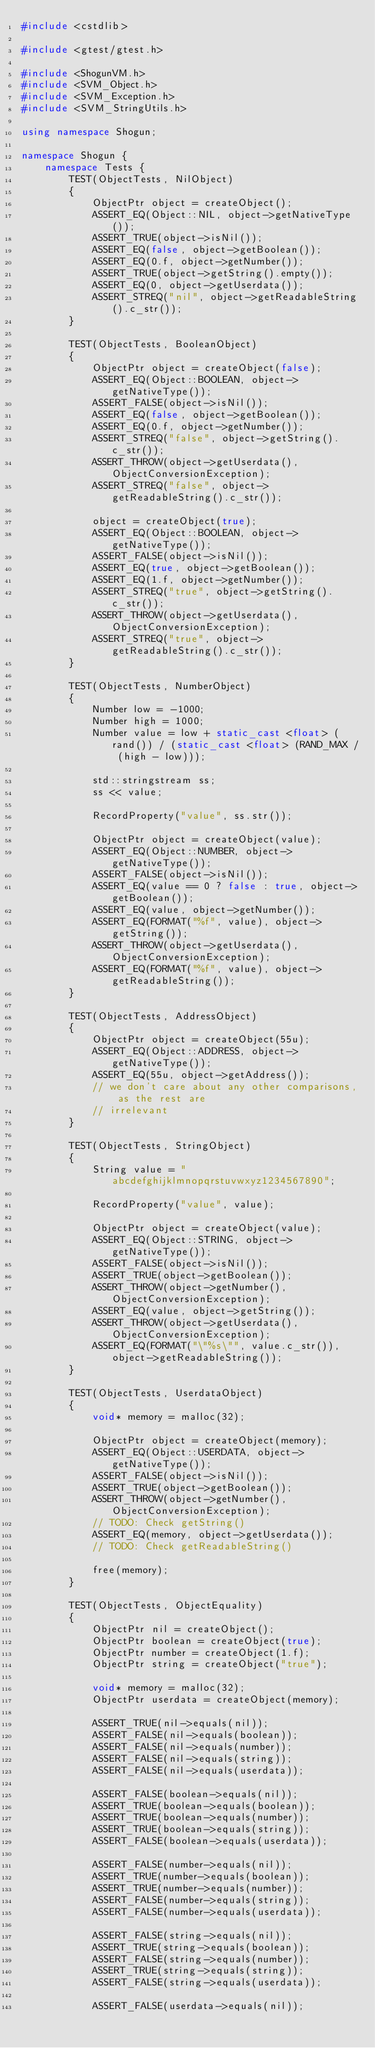Convert code to text. <code><loc_0><loc_0><loc_500><loc_500><_C++_>#include <cstdlib>

#include <gtest/gtest.h>

#include <ShogunVM.h>
#include <SVM_Object.h>
#include <SVM_Exception.h>
#include <SVM_StringUtils.h>

using namespace Shogun;

namespace Shogun {
	namespace Tests {
		TEST(ObjectTests, NilObject)
		{
			ObjectPtr object = createObject();
			ASSERT_EQ(Object::NIL, object->getNativeType());
			ASSERT_TRUE(object->isNil());
			ASSERT_EQ(false, object->getBoolean());
			ASSERT_EQ(0.f, object->getNumber());
			ASSERT_TRUE(object->getString().empty());
			ASSERT_EQ(0, object->getUserdata());
			ASSERT_STREQ("nil", object->getReadableString().c_str());
		}

		TEST(ObjectTests, BooleanObject)
		{
			ObjectPtr object = createObject(false);
			ASSERT_EQ(Object::BOOLEAN, object->getNativeType());
			ASSERT_FALSE(object->isNil());
			ASSERT_EQ(false, object->getBoolean());
			ASSERT_EQ(0.f, object->getNumber());
			ASSERT_STREQ("false", object->getString().c_str());
			ASSERT_THROW(object->getUserdata(), ObjectConversionException);
			ASSERT_STREQ("false", object->getReadableString().c_str());

			object = createObject(true);
			ASSERT_EQ(Object::BOOLEAN, object->getNativeType());
			ASSERT_FALSE(object->isNil());
			ASSERT_EQ(true, object->getBoolean());
			ASSERT_EQ(1.f, object->getNumber());
			ASSERT_STREQ("true", object->getString().c_str());
			ASSERT_THROW(object->getUserdata(), ObjectConversionException);
			ASSERT_STREQ("true", object->getReadableString().c_str());
		}

		TEST(ObjectTests, NumberObject)
		{
			Number low = -1000;
			Number high = 1000;
			Number value = low + static_cast <float> (rand()) / (static_cast <float> (RAND_MAX / (high - low)));
			
			std::stringstream ss;
			ss << value;

			RecordProperty("value", ss.str());

			ObjectPtr object = createObject(value);
			ASSERT_EQ(Object::NUMBER, object->getNativeType());
			ASSERT_FALSE(object->isNil());
			ASSERT_EQ(value == 0 ? false : true, object->getBoolean());
			ASSERT_EQ(value, object->getNumber());
			ASSERT_EQ(FORMAT("%f", value), object->getString());
			ASSERT_THROW(object->getUserdata(), ObjectConversionException);
			ASSERT_EQ(FORMAT("%f", value), object->getReadableString());
		}

		TEST(ObjectTests, AddressObject)
		{
			ObjectPtr object = createObject(55u);
			ASSERT_EQ(Object::ADDRESS, object->getNativeType());
			ASSERT_EQ(55u, object->getAddress());
			// we don't care about any other comparisons, as the rest are
			// irrelevant
		}

		TEST(ObjectTests, StringObject)
		{
			String value = "abcdefghijklmnopqrstuvwxyz1234567890";

			RecordProperty("value", value);

			ObjectPtr object = createObject(value);
			ASSERT_EQ(Object::STRING, object->getNativeType());
			ASSERT_FALSE(object->isNil());
			ASSERT_TRUE(object->getBoolean());
			ASSERT_THROW(object->getNumber(), ObjectConversionException);
			ASSERT_EQ(value, object->getString());
			ASSERT_THROW(object->getUserdata(), ObjectConversionException);
			ASSERT_EQ(FORMAT("\"%s\"", value.c_str()), object->getReadableString());
		}

		TEST(ObjectTests, UserdataObject)
		{
			void* memory = malloc(32);

			ObjectPtr object = createObject(memory);
			ASSERT_EQ(Object::USERDATA, object->getNativeType());
			ASSERT_FALSE(object->isNil());
			ASSERT_TRUE(object->getBoolean());
			ASSERT_THROW(object->getNumber(), ObjectConversionException);
			// TODO: Check getString()
			ASSERT_EQ(memory, object->getUserdata());
			// TODO: Check getReadableString()

			free(memory);
		}

		TEST(ObjectTests, ObjectEquality)
		{
			ObjectPtr nil = createObject();
			ObjectPtr boolean = createObject(true);
			ObjectPtr number = createObject(1.f);
			ObjectPtr string = createObject("true");

			void* memory = malloc(32);
			ObjectPtr userdata = createObject(memory);

			ASSERT_TRUE(nil->equals(nil));
			ASSERT_FALSE(nil->equals(boolean));
			ASSERT_FALSE(nil->equals(number));
			ASSERT_FALSE(nil->equals(string));
			ASSERT_FALSE(nil->equals(userdata));

			ASSERT_FALSE(boolean->equals(nil));
			ASSERT_TRUE(boolean->equals(boolean));
			ASSERT_TRUE(boolean->equals(number));
			ASSERT_TRUE(boolean->equals(string));
			ASSERT_FALSE(boolean->equals(userdata));

			ASSERT_FALSE(number->equals(nil));
			ASSERT_TRUE(number->equals(boolean));
			ASSERT_TRUE(number->equals(number));
			ASSERT_FALSE(number->equals(string));
			ASSERT_FALSE(number->equals(userdata));

			ASSERT_FALSE(string->equals(nil));
			ASSERT_TRUE(string->equals(boolean));
			ASSERT_FALSE(string->equals(number));
			ASSERT_TRUE(string->equals(string));
			ASSERT_FALSE(string->equals(userdata));

			ASSERT_FALSE(userdata->equals(nil));</code> 